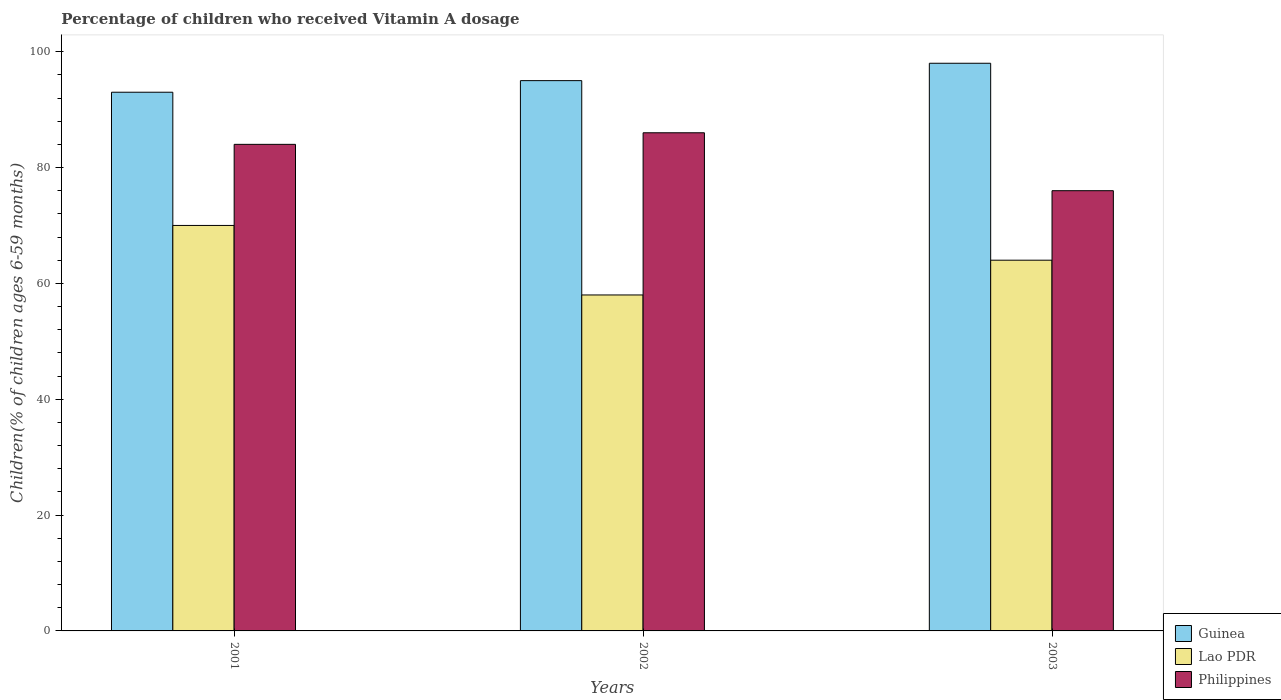Are the number of bars per tick equal to the number of legend labels?
Provide a succinct answer. Yes. How many bars are there on the 3rd tick from the right?
Make the answer very short. 3. Across all years, what is the minimum percentage of children who received Vitamin A dosage in Guinea?
Your answer should be compact. 93. In which year was the percentage of children who received Vitamin A dosage in Lao PDR maximum?
Your response must be concise. 2001. In which year was the percentage of children who received Vitamin A dosage in Guinea minimum?
Keep it short and to the point. 2001. What is the total percentage of children who received Vitamin A dosage in Philippines in the graph?
Provide a succinct answer. 246. What is the difference between the percentage of children who received Vitamin A dosage in Lao PDR in 2003 and the percentage of children who received Vitamin A dosage in Philippines in 2001?
Ensure brevity in your answer.  -20. In the year 2003, what is the difference between the percentage of children who received Vitamin A dosage in Philippines and percentage of children who received Vitamin A dosage in Guinea?
Provide a succinct answer. -22. In how many years, is the percentage of children who received Vitamin A dosage in Guinea greater than 32 %?
Your response must be concise. 3. What is the ratio of the percentage of children who received Vitamin A dosage in Philippines in 2001 to that in 2003?
Provide a succinct answer. 1.11. Is the percentage of children who received Vitamin A dosage in Guinea in 2001 less than that in 2003?
Give a very brief answer. Yes. What is the difference between the highest and the second highest percentage of children who received Vitamin A dosage in Guinea?
Keep it short and to the point. 3. In how many years, is the percentage of children who received Vitamin A dosage in Philippines greater than the average percentage of children who received Vitamin A dosage in Philippines taken over all years?
Give a very brief answer. 2. What does the 3rd bar from the left in 2003 represents?
Your answer should be compact. Philippines. Is it the case that in every year, the sum of the percentage of children who received Vitamin A dosage in Lao PDR and percentage of children who received Vitamin A dosage in Philippines is greater than the percentage of children who received Vitamin A dosage in Guinea?
Your answer should be compact. Yes. How many bars are there?
Ensure brevity in your answer.  9. What is the difference between two consecutive major ticks on the Y-axis?
Provide a succinct answer. 20. How many legend labels are there?
Offer a very short reply. 3. What is the title of the graph?
Keep it short and to the point. Percentage of children who received Vitamin A dosage. Does "Mauritius" appear as one of the legend labels in the graph?
Your answer should be compact. No. What is the label or title of the X-axis?
Your answer should be compact. Years. What is the label or title of the Y-axis?
Keep it short and to the point. Children(% of children ages 6-59 months). What is the Children(% of children ages 6-59 months) of Guinea in 2001?
Your response must be concise. 93. What is the Children(% of children ages 6-59 months) of Guinea in 2002?
Give a very brief answer. 95. What is the Children(% of children ages 6-59 months) in Lao PDR in 2002?
Keep it short and to the point. 58. What is the Children(% of children ages 6-59 months) in Guinea in 2003?
Your response must be concise. 98. What is the Children(% of children ages 6-59 months) of Lao PDR in 2003?
Offer a very short reply. 64. Across all years, what is the maximum Children(% of children ages 6-59 months) in Guinea?
Ensure brevity in your answer.  98. Across all years, what is the maximum Children(% of children ages 6-59 months) in Lao PDR?
Your answer should be compact. 70. Across all years, what is the minimum Children(% of children ages 6-59 months) of Guinea?
Keep it short and to the point. 93. Across all years, what is the minimum Children(% of children ages 6-59 months) of Lao PDR?
Your answer should be compact. 58. Across all years, what is the minimum Children(% of children ages 6-59 months) in Philippines?
Ensure brevity in your answer.  76. What is the total Children(% of children ages 6-59 months) in Guinea in the graph?
Your answer should be very brief. 286. What is the total Children(% of children ages 6-59 months) of Lao PDR in the graph?
Provide a succinct answer. 192. What is the total Children(% of children ages 6-59 months) of Philippines in the graph?
Your response must be concise. 246. What is the difference between the Children(% of children ages 6-59 months) of Guinea in 2001 and that in 2002?
Ensure brevity in your answer.  -2. What is the difference between the Children(% of children ages 6-59 months) in Lao PDR in 2002 and that in 2003?
Offer a very short reply. -6. What is the difference between the Children(% of children ages 6-59 months) in Philippines in 2002 and that in 2003?
Ensure brevity in your answer.  10. What is the difference between the Children(% of children ages 6-59 months) in Guinea in 2001 and the Children(% of children ages 6-59 months) in Lao PDR in 2003?
Give a very brief answer. 29. What is the difference between the Children(% of children ages 6-59 months) in Guinea in 2001 and the Children(% of children ages 6-59 months) in Philippines in 2003?
Offer a terse response. 17. What is the difference between the Children(% of children ages 6-59 months) in Lao PDR in 2001 and the Children(% of children ages 6-59 months) in Philippines in 2003?
Provide a succinct answer. -6. What is the difference between the Children(% of children ages 6-59 months) of Lao PDR in 2002 and the Children(% of children ages 6-59 months) of Philippines in 2003?
Provide a succinct answer. -18. What is the average Children(% of children ages 6-59 months) in Guinea per year?
Your response must be concise. 95.33. What is the average Children(% of children ages 6-59 months) of Lao PDR per year?
Give a very brief answer. 64. What is the average Children(% of children ages 6-59 months) of Philippines per year?
Ensure brevity in your answer.  82. In the year 2001, what is the difference between the Children(% of children ages 6-59 months) in Lao PDR and Children(% of children ages 6-59 months) in Philippines?
Make the answer very short. -14. What is the ratio of the Children(% of children ages 6-59 months) of Guinea in 2001 to that in 2002?
Your answer should be compact. 0.98. What is the ratio of the Children(% of children ages 6-59 months) of Lao PDR in 2001 to that in 2002?
Give a very brief answer. 1.21. What is the ratio of the Children(% of children ages 6-59 months) in Philippines in 2001 to that in 2002?
Provide a succinct answer. 0.98. What is the ratio of the Children(% of children ages 6-59 months) in Guinea in 2001 to that in 2003?
Make the answer very short. 0.95. What is the ratio of the Children(% of children ages 6-59 months) of Lao PDR in 2001 to that in 2003?
Provide a succinct answer. 1.09. What is the ratio of the Children(% of children ages 6-59 months) of Philippines in 2001 to that in 2003?
Keep it short and to the point. 1.11. What is the ratio of the Children(% of children ages 6-59 months) of Guinea in 2002 to that in 2003?
Ensure brevity in your answer.  0.97. What is the ratio of the Children(% of children ages 6-59 months) of Lao PDR in 2002 to that in 2003?
Your answer should be very brief. 0.91. What is the ratio of the Children(% of children ages 6-59 months) in Philippines in 2002 to that in 2003?
Provide a succinct answer. 1.13. What is the difference between the highest and the second highest Children(% of children ages 6-59 months) of Guinea?
Provide a succinct answer. 3. What is the difference between the highest and the lowest Children(% of children ages 6-59 months) of Guinea?
Ensure brevity in your answer.  5. What is the difference between the highest and the lowest Children(% of children ages 6-59 months) of Lao PDR?
Your answer should be very brief. 12. What is the difference between the highest and the lowest Children(% of children ages 6-59 months) in Philippines?
Ensure brevity in your answer.  10. 